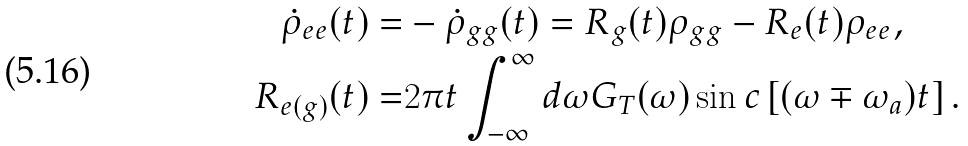<formula> <loc_0><loc_0><loc_500><loc_500>\dot { \rho } _ { e e } ( t ) = & - \dot { \rho } _ { g g } ( t ) = R _ { g } ( t ) \rho _ { g g } - R _ { e } ( t ) \rho _ { e e } , \\ R _ { e ( g ) } ( t ) = & 2 \pi t \int _ { - \infty } ^ { \infty } d \omega G _ { T } ( \omega ) \sin c \left [ ( \omega \mp \omega _ { a } ) t \right ] .</formula> 